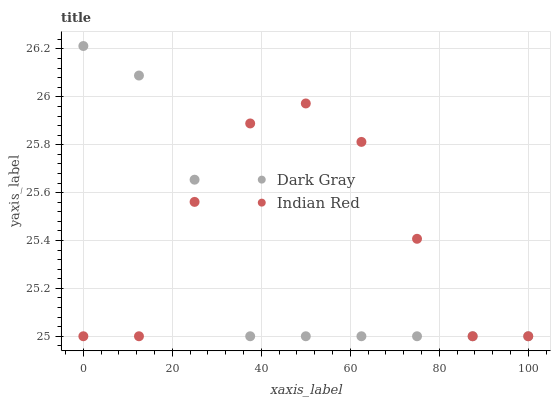Does Dark Gray have the minimum area under the curve?
Answer yes or no. Yes. Does Indian Red have the maximum area under the curve?
Answer yes or no. Yes. Does Indian Red have the minimum area under the curve?
Answer yes or no. No. Is Dark Gray the smoothest?
Answer yes or no. Yes. Is Indian Red the roughest?
Answer yes or no. Yes. Is Indian Red the smoothest?
Answer yes or no. No. Does Dark Gray have the lowest value?
Answer yes or no. Yes. Does Dark Gray have the highest value?
Answer yes or no. Yes. Does Indian Red have the highest value?
Answer yes or no. No. Does Indian Red intersect Dark Gray?
Answer yes or no. Yes. Is Indian Red less than Dark Gray?
Answer yes or no. No. Is Indian Red greater than Dark Gray?
Answer yes or no. No. 